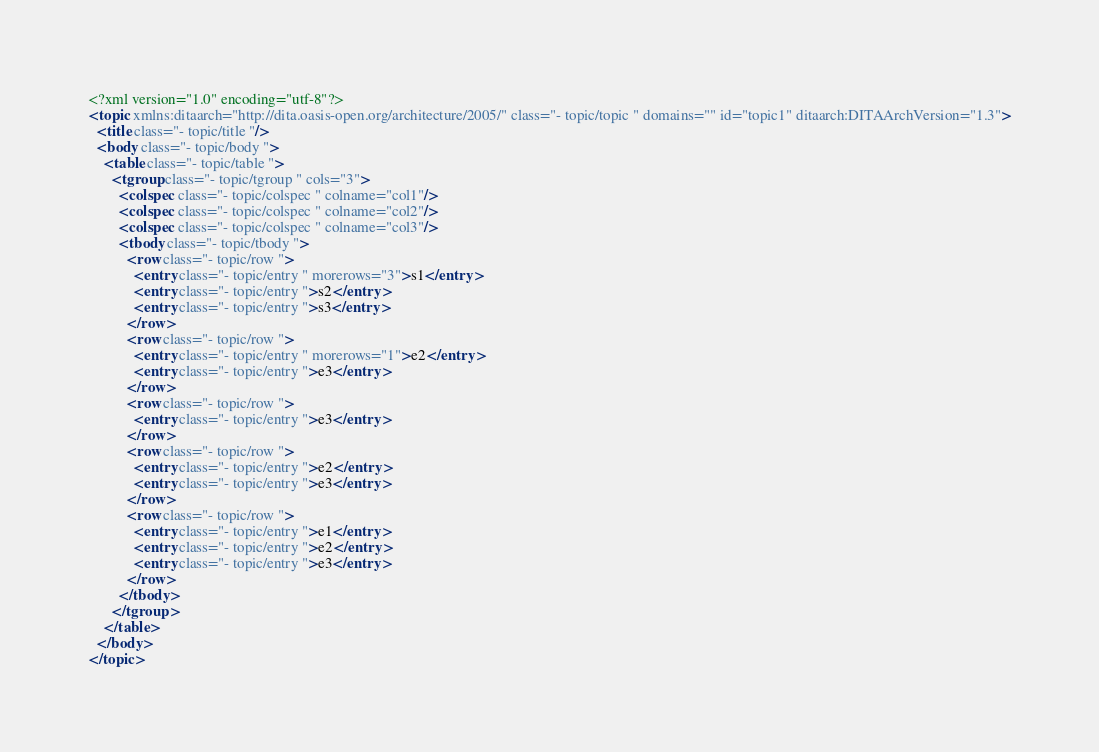<code> <loc_0><loc_0><loc_500><loc_500><_XML_><?xml version="1.0" encoding="utf-8"?>
<topic xmlns:ditaarch="http://dita.oasis-open.org/architecture/2005/" class="- topic/topic " domains="" id="topic1" ditaarch:DITAArchVersion="1.3">
  <title class="- topic/title "/>
  <body class="- topic/body ">
    <table class="- topic/table ">
      <tgroup class="- topic/tgroup " cols="3">
        <colspec class="- topic/colspec " colname="col1"/>
        <colspec class="- topic/colspec " colname="col2"/>
        <colspec class="- topic/colspec " colname="col3"/>
        <tbody class="- topic/tbody ">
          <row class="- topic/row ">
            <entry class="- topic/entry " morerows="3">s1</entry>
            <entry class="- topic/entry ">s2</entry>
            <entry class="- topic/entry ">s3</entry>
          </row>
          <row class="- topic/row ">
            <entry class="- topic/entry " morerows="1">e2</entry>
            <entry class="- topic/entry ">e3</entry>
          </row>
          <row class="- topic/row ">
            <entry class="- topic/entry ">e3</entry>
          </row>
          <row class="- topic/row ">
            <entry class="- topic/entry ">e2</entry>
            <entry class="- topic/entry ">e3</entry>
          </row>
          <row class="- topic/row ">
            <entry class="- topic/entry ">e1</entry>
            <entry class="- topic/entry ">e2</entry>
            <entry class="- topic/entry ">e3</entry>
          </row>
        </tbody>
      </tgroup>
    </table>
  </body>
</topic>
</code> 